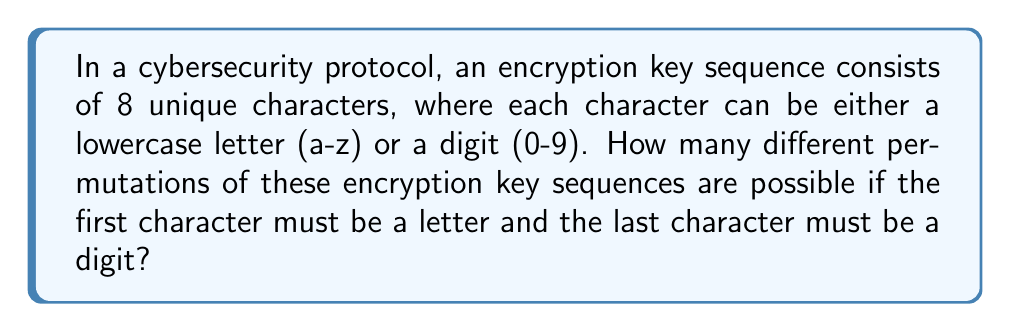Show me your answer to this math problem. Let's approach this step-by-step:

1) First, we need to determine the number of choices for each position in the sequence:
   - For the first position (must be a letter): 26 choices
   - For the last position (must be a digit): 10 choices
   - For the remaining 6 positions: 34 choices each (26 letters + 8 digits, as we've used 2 digits already)

2) Now, let's use the multiplication principle of counting:

   $$26 \times 34 \times 34 \times 34 \times 34 \times 34 \times 34 \times 10$$

3) This can be simplified to:

   $$26 \times 34^6 \times 10$$

4) Let's calculate this:
   $$26 \times (34^6) \times 10 = 26 \times 1,544,804,416 \times 10 = 401,649,148,160$$

Therefore, there are 401,649,148,160 possible permutations of encryption key sequences that satisfy the given conditions.
Answer: $401,649,148,160$ 